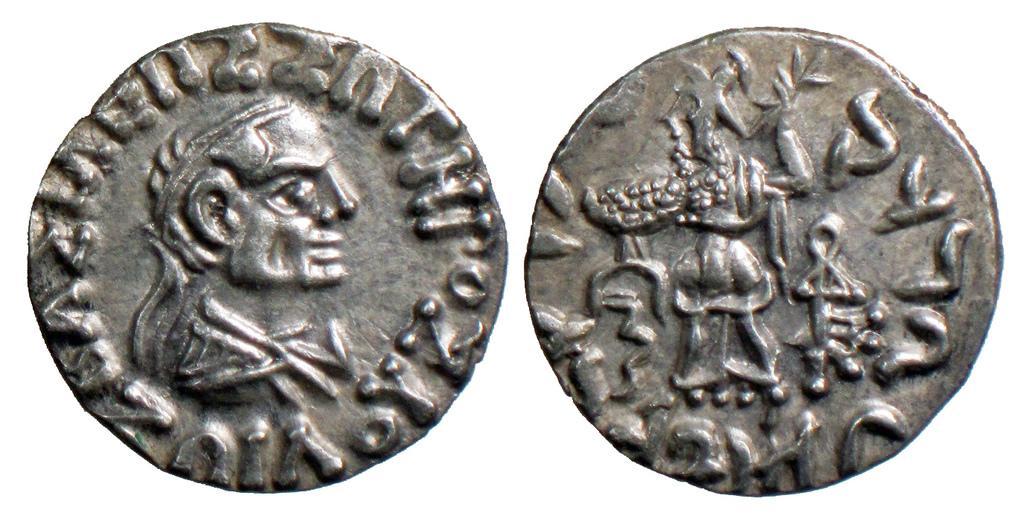Could you give a brief overview of what you see in this image? In this image there are coins with letters and pictures on it. 